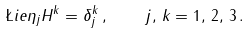Convert formula to latex. <formula><loc_0><loc_0><loc_500><loc_500>\L i e { \eta _ { j } } { H ^ { k } } = \delta ^ { k } _ { j } \, , \quad j , \, k = 1 , \, 2 , \, 3 \, .</formula> 